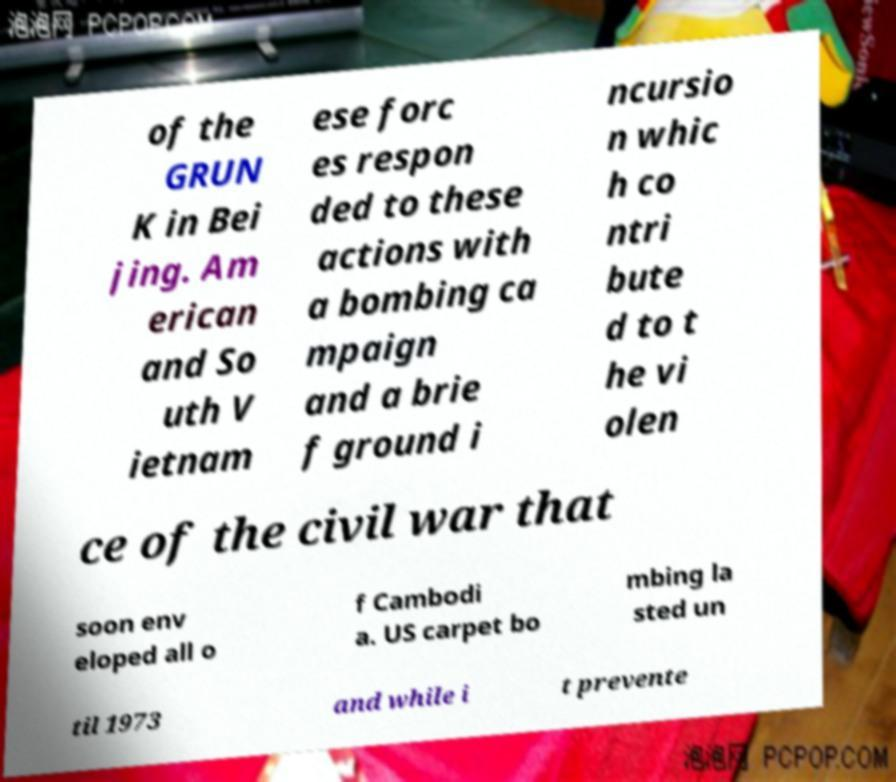Could you extract and type out the text from this image? of the GRUN K in Bei jing. Am erican and So uth V ietnam ese forc es respon ded to these actions with a bombing ca mpaign and a brie f ground i ncursio n whic h co ntri bute d to t he vi olen ce of the civil war that soon env eloped all o f Cambodi a. US carpet bo mbing la sted un til 1973 and while i t prevente 